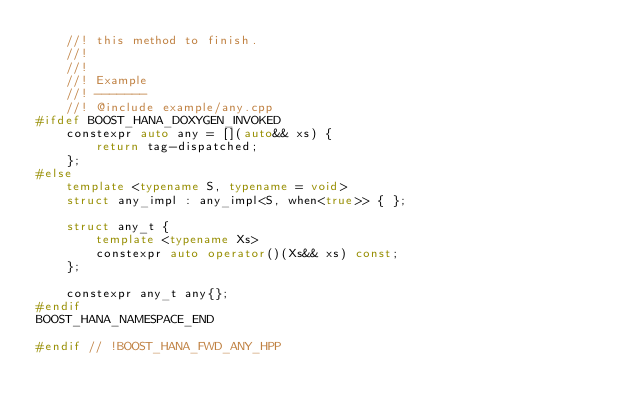<code> <loc_0><loc_0><loc_500><loc_500><_C++_>    //! this method to finish.
    //!
    //!
    //! Example
    //! -------
    //! @include example/any.cpp
#ifdef BOOST_HANA_DOXYGEN_INVOKED
    constexpr auto any = [](auto&& xs) {
        return tag-dispatched;
    };
#else
    template <typename S, typename = void>
    struct any_impl : any_impl<S, when<true>> { };

    struct any_t {
        template <typename Xs>
        constexpr auto operator()(Xs&& xs) const;
    };

    constexpr any_t any{};
#endif
BOOST_HANA_NAMESPACE_END

#endif // !BOOST_HANA_FWD_ANY_HPP
</code> 